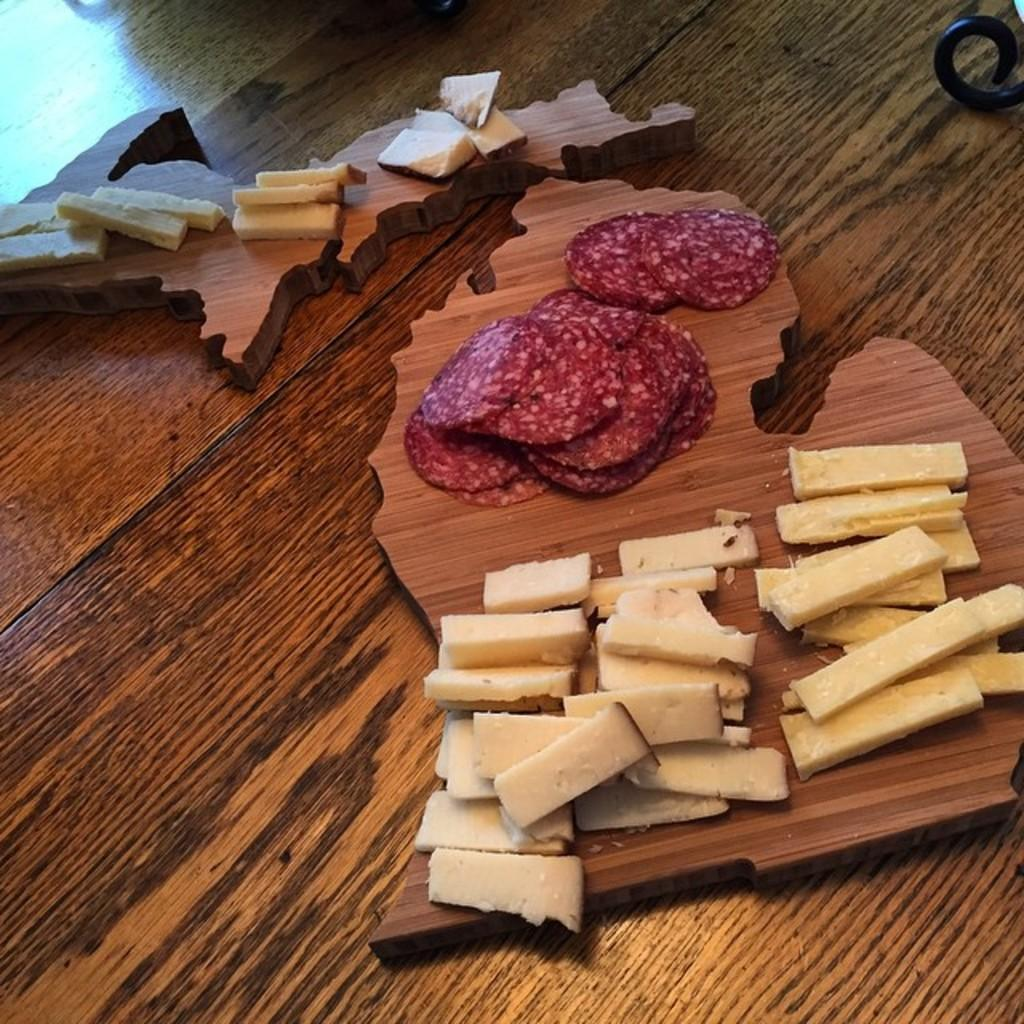What type of food can be seen in the image? There is meat in the image. How is the food presented in the image? The food is on wooden boards in the image. What can be seen in the background of the image? There is a table visible in the background of the image. How does the earthquake affect the wooden boards in the image? There is no earthquake present in the image, so its effects cannot be observed. 